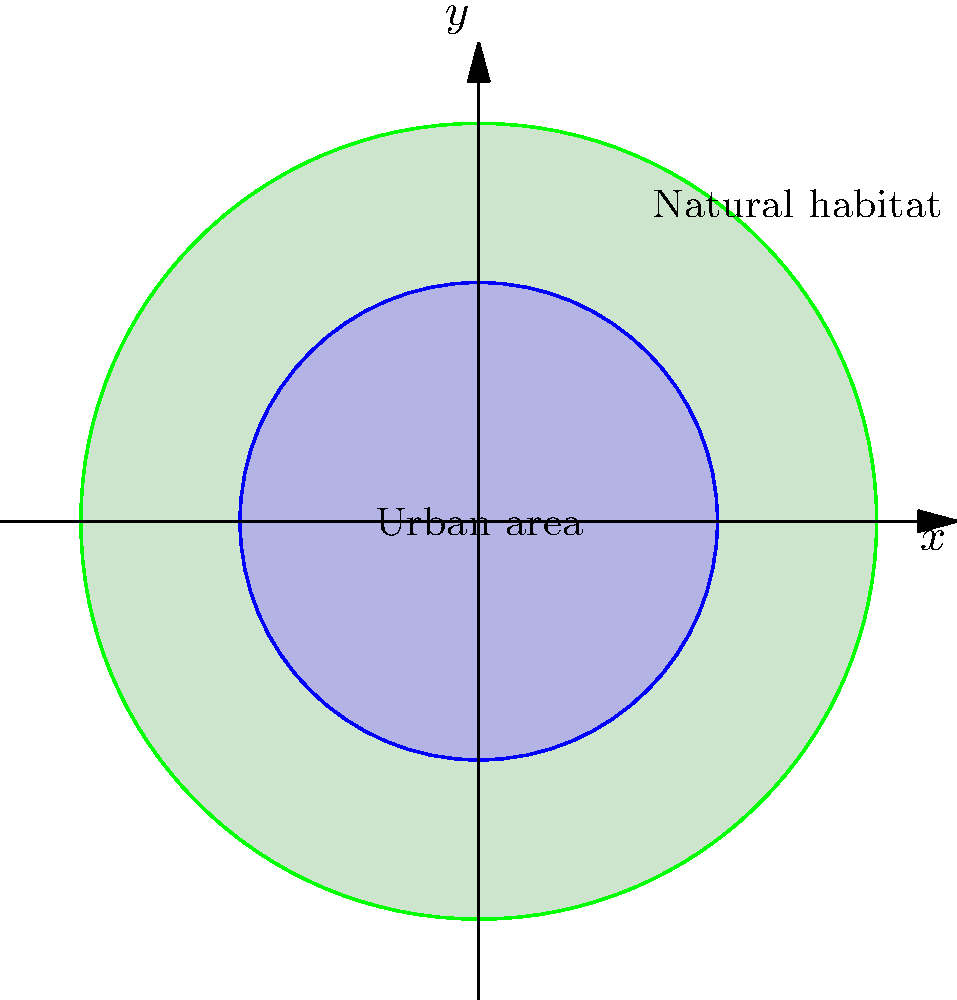A city's urban area is represented by the inner circle, while the surrounding natural habitat is represented by the area between the inner and outer circles. If the radius of the urban area increases from 3 units to 4.5 units over a 10-year period due to urban sprawl, what is the scale factor of this dilation? How does this growth impact the area of the natural habitat, and what percentage of the original natural habitat area is lost? Let's approach this step-by-step:

1) First, let's calculate the scale factor of the dilation:
   Initial radius = 3 units
   Final radius = 4.5 units
   Scale factor = Final radius / Initial radius = 4.5 / 3 = 1.5

2) Now, let's calculate the areas:
   Initial urban area: $A_1 = \pi r_1^2 = \pi(3^2) = 9\pi$ sq units
   Final urban area: $A_2 = \pi r_2^2 = \pi(4.5^2) = 20.25\pi$ sq units

3) Initial natural habitat area:
   $A_{h1} = \pi(5^2 - 3^2) = \pi(25 - 9) = 16\pi$ sq units

4) Final natural habitat area:
   $A_{h2} = \pi(5^2 - 4.5^2) = \pi(25 - 20.25) = 4.75\pi$ sq units

5) Area of natural habitat lost:
   $A_{lost} = A_{h1} - A_{h2} = 16\pi - 4.75\pi = 11.25\pi$ sq units

6) Percentage of original natural habitat lost:
   $(A_{lost} / A_{h1}) \times 100\% = (11.25\pi / 16\pi) \times 100\% = 70.3125\%$

Therefore, the scale factor of the dilation is 1.5, and 70.3125% of the original natural habitat area is lost due to urban sprawl.
Answer: Scale factor: 1.5; Percentage of natural habitat lost: 70.3125% 